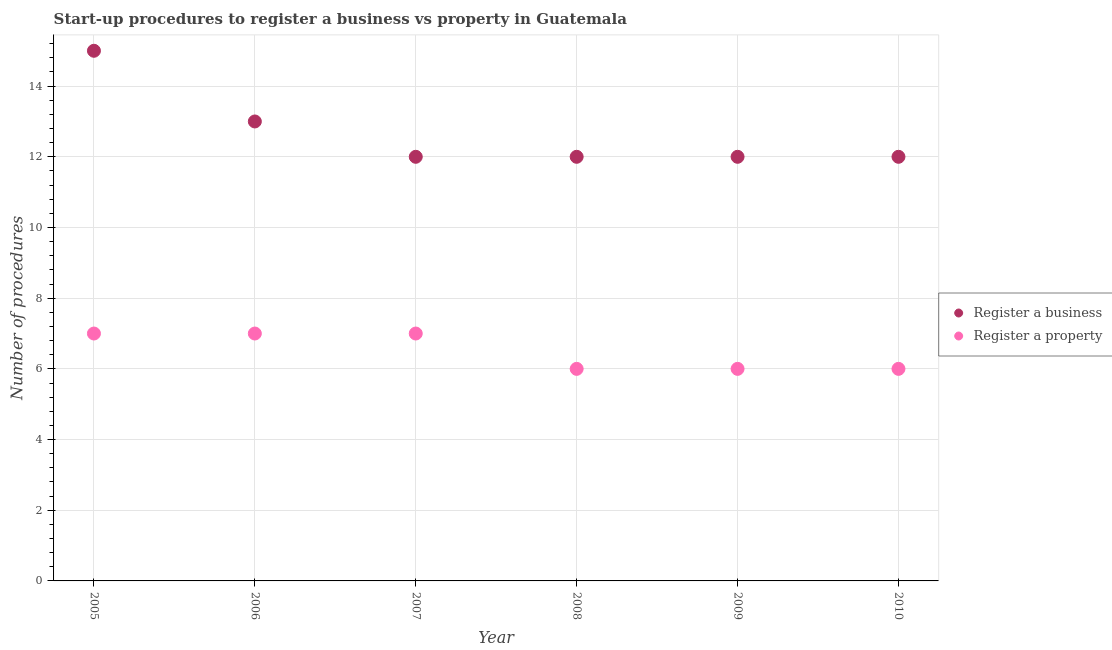What is the number of procedures to register a business in 2010?
Your response must be concise. 12. Across all years, what is the maximum number of procedures to register a property?
Offer a very short reply. 7. Across all years, what is the minimum number of procedures to register a property?
Provide a short and direct response. 6. In which year was the number of procedures to register a property maximum?
Make the answer very short. 2005. What is the total number of procedures to register a business in the graph?
Keep it short and to the point. 76. What is the difference between the number of procedures to register a property in 2007 and that in 2009?
Keep it short and to the point. 1. What is the difference between the number of procedures to register a property in 2010 and the number of procedures to register a business in 2005?
Offer a very short reply. -9. In the year 2007, what is the difference between the number of procedures to register a property and number of procedures to register a business?
Your response must be concise. -5. Is the difference between the number of procedures to register a business in 2006 and 2009 greater than the difference between the number of procedures to register a property in 2006 and 2009?
Ensure brevity in your answer.  No. What is the difference between the highest and the second highest number of procedures to register a property?
Provide a succinct answer. 0. What is the difference between the highest and the lowest number of procedures to register a property?
Your answer should be compact. 1. Does the number of procedures to register a property monotonically increase over the years?
Keep it short and to the point. No. Is the number of procedures to register a business strictly greater than the number of procedures to register a property over the years?
Your answer should be very brief. Yes. Are the values on the major ticks of Y-axis written in scientific E-notation?
Offer a terse response. No. Does the graph contain any zero values?
Provide a succinct answer. No. What is the title of the graph?
Keep it short and to the point. Start-up procedures to register a business vs property in Guatemala. Does "Primary school" appear as one of the legend labels in the graph?
Offer a terse response. No. What is the label or title of the X-axis?
Give a very brief answer. Year. What is the label or title of the Y-axis?
Give a very brief answer. Number of procedures. What is the Number of procedures of Register a business in 2005?
Your response must be concise. 15. What is the Number of procedures of Register a property in 2005?
Provide a succinct answer. 7. What is the Number of procedures in Register a property in 2006?
Offer a terse response. 7. What is the Number of procedures in Register a business in 2007?
Your answer should be very brief. 12. What is the Number of procedures in Register a business in 2008?
Your answer should be very brief. 12. What is the Number of procedures of Register a business in 2009?
Provide a succinct answer. 12. What is the Number of procedures in Register a business in 2010?
Your answer should be compact. 12. What is the Number of procedures of Register a property in 2010?
Your answer should be very brief. 6. Across all years, what is the maximum Number of procedures of Register a business?
Provide a succinct answer. 15. Across all years, what is the maximum Number of procedures in Register a property?
Give a very brief answer. 7. Across all years, what is the minimum Number of procedures of Register a business?
Offer a terse response. 12. What is the difference between the Number of procedures of Register a business in 2005 and that in 2006?
Your answer should be compact. 2. What is the difference between the Number of procedures of Register a property in 2005 and that in 2006?
Provide a succinct answer. 0. What is the difference between the Number of procedures in Register a business in 2005 and that in 2010?
Your response must be concise. 3. What is the difference between the Number of procedures in Register a business in 2006 and that in 2007?
Give a very brief answer. 1. What is the difference between the Number of procedures in Register a property in 2006 and that in 2008?
Your answer should be very brief. 1. What is the difference between the Number of procedures of Register a business in 2006 and that in 2009?
Keep it short and to the point. 1. What is the difference between the Number of procedures of Register a business in 2007 and that in 2008?
Ensure brevity in your answer.  0. What is the difference between the Number of procedures of Register a property in 2007 and that in 2009?
Ensure brevity in your answer.  1. What is the difference between the Number of procedures in Register a business in 2008 and that in 2009?
Give a very brief answer. 0. What is the difference between the Number of procedures of Register a property in 2008 and that in 2009?
Give a very brief answer. 0. What is the difference between the Number of procedures in Register a business in 2009 and that in 2010?
Offer a terse response. 0. What is the difference between the Number of procedures in Register a property in 2009 and that in 2010?
Provide a short and direct response. 0. What is the difference between the Number of procedures of Register a business in 2005 and the Number of procedures of Register a property in 2010?
Ensure brevity in your answer.  9. What is the difference between the Number of procedures of Register a business in 2006 and the Number of procedures of Register a property in 2007?
Your answer should be very brief. 6. What is the difference between the Number of procedures in Register a business in 2006 and the Number of procedures in Register a property in 2009?
Give a very brief answer. 7. What is the difference between the Number of procedures of Register a business in 2006 and the Number of procedures of Register a property in 2010?
Your answer should be very brief. 7. What is the difference between the Number of procedures of Register a business in 2007 and the Number of procedures of Register a property in 2008?
Offer a terse response. 6. What is the difference between the Number of procedures in Register a business in 2007 and the Number of procedures in Register a property in 2010?
Your answer should be compact. 6. What is the difference between the Number of procedures in Register a business in 2008 and the Number of procedures in Register a property in 2009?
Your answer should be compact. 6. What is the difference between the Number of procedures in Register a business in 2009 and the Number of procedures in Register a property in 2010?
Offer a terse response. 6. What is the average Number of procedures of Register a business per year?
Offer a terse response. 12.67. In the year 2005, what is the difference between the Number of procedures in Register a business and Number of procedures in Register a property?
Ensure brevity in your answer.  8. In the year 2006, what is the difference between the Number of procedures in Register a business and Number of procedures in Register a property?
Keep it short and to the point. 6. In the year 2009, what is the difference between the Number of procedures in Register a business and Number of procedures in Register a property?
Make the answer very short. 6. What is the ratio of the Number of procedures of Register a business in 2005 to that in 2006?
Your answer should be very brief. 1.15. What is the ratio of the Number of procedures in Register a property in 2005 to that in 2006?
Provide a succinct answer. 1. What is the ratio of the Number of procedures in Register a business in 2005 to that in 2007?
Your response must be concise. 1.25. What is the ratio of the Number of procedures in Register a business in 2005 to that in 2008?
Offer a terse response. 1.25. What is the ratio of the Number of procedures in Register a business in 2005 to that in 2009?
Offer a very short reply. 1.25. What is the ratio of the Number of procedures in Register a business in 2006 to that in 2008?
Give a very brief answer. 1.08. What is the ratio of the Number of procedures of Register a business in 2006 to that in 2009?
Give a very brief answer. 1.08. What is the ratio of the Number of procedures in Register a property in 2006 to that in 2009?
Provide a short and direct response. 1.17. What is the ratio of the Number of procedures of Register a property in 2006 to that in 2010?
Provide a short and direct response. 1.17. What is the ratio of the Number of procedures in Register a business in 2007 to that in 2009?
Keep it short and to the point. 1. What is the ratio of the Number of procedures in Register a property in 2007 to that in 2010?
Keep it short and to the point. 1.17. What is the ratio of the Number of procedures in Register a business in 2008 to that in 2009?
Your answer should be compact. 1. What is the ratio of the Number of procedures of Register a property in 2008 to that in 2009?
Offer a very short reply. 1. What is the ratio of the Number of procedures in Register a business in 2009 to that in 2010?
Keep it short and to the point. 1. What is the ratio of the Number of procedures in Register a property in 2009 to that in 2010?
Your response must be concise. 1. What is the difference between the highest and the second highest Number of procedures in Register a property?
Offer a very short reply. 0. What is the difference between the highest and the lowest Number of procedures in Register a property?
Your answer should be very brief. 1. 